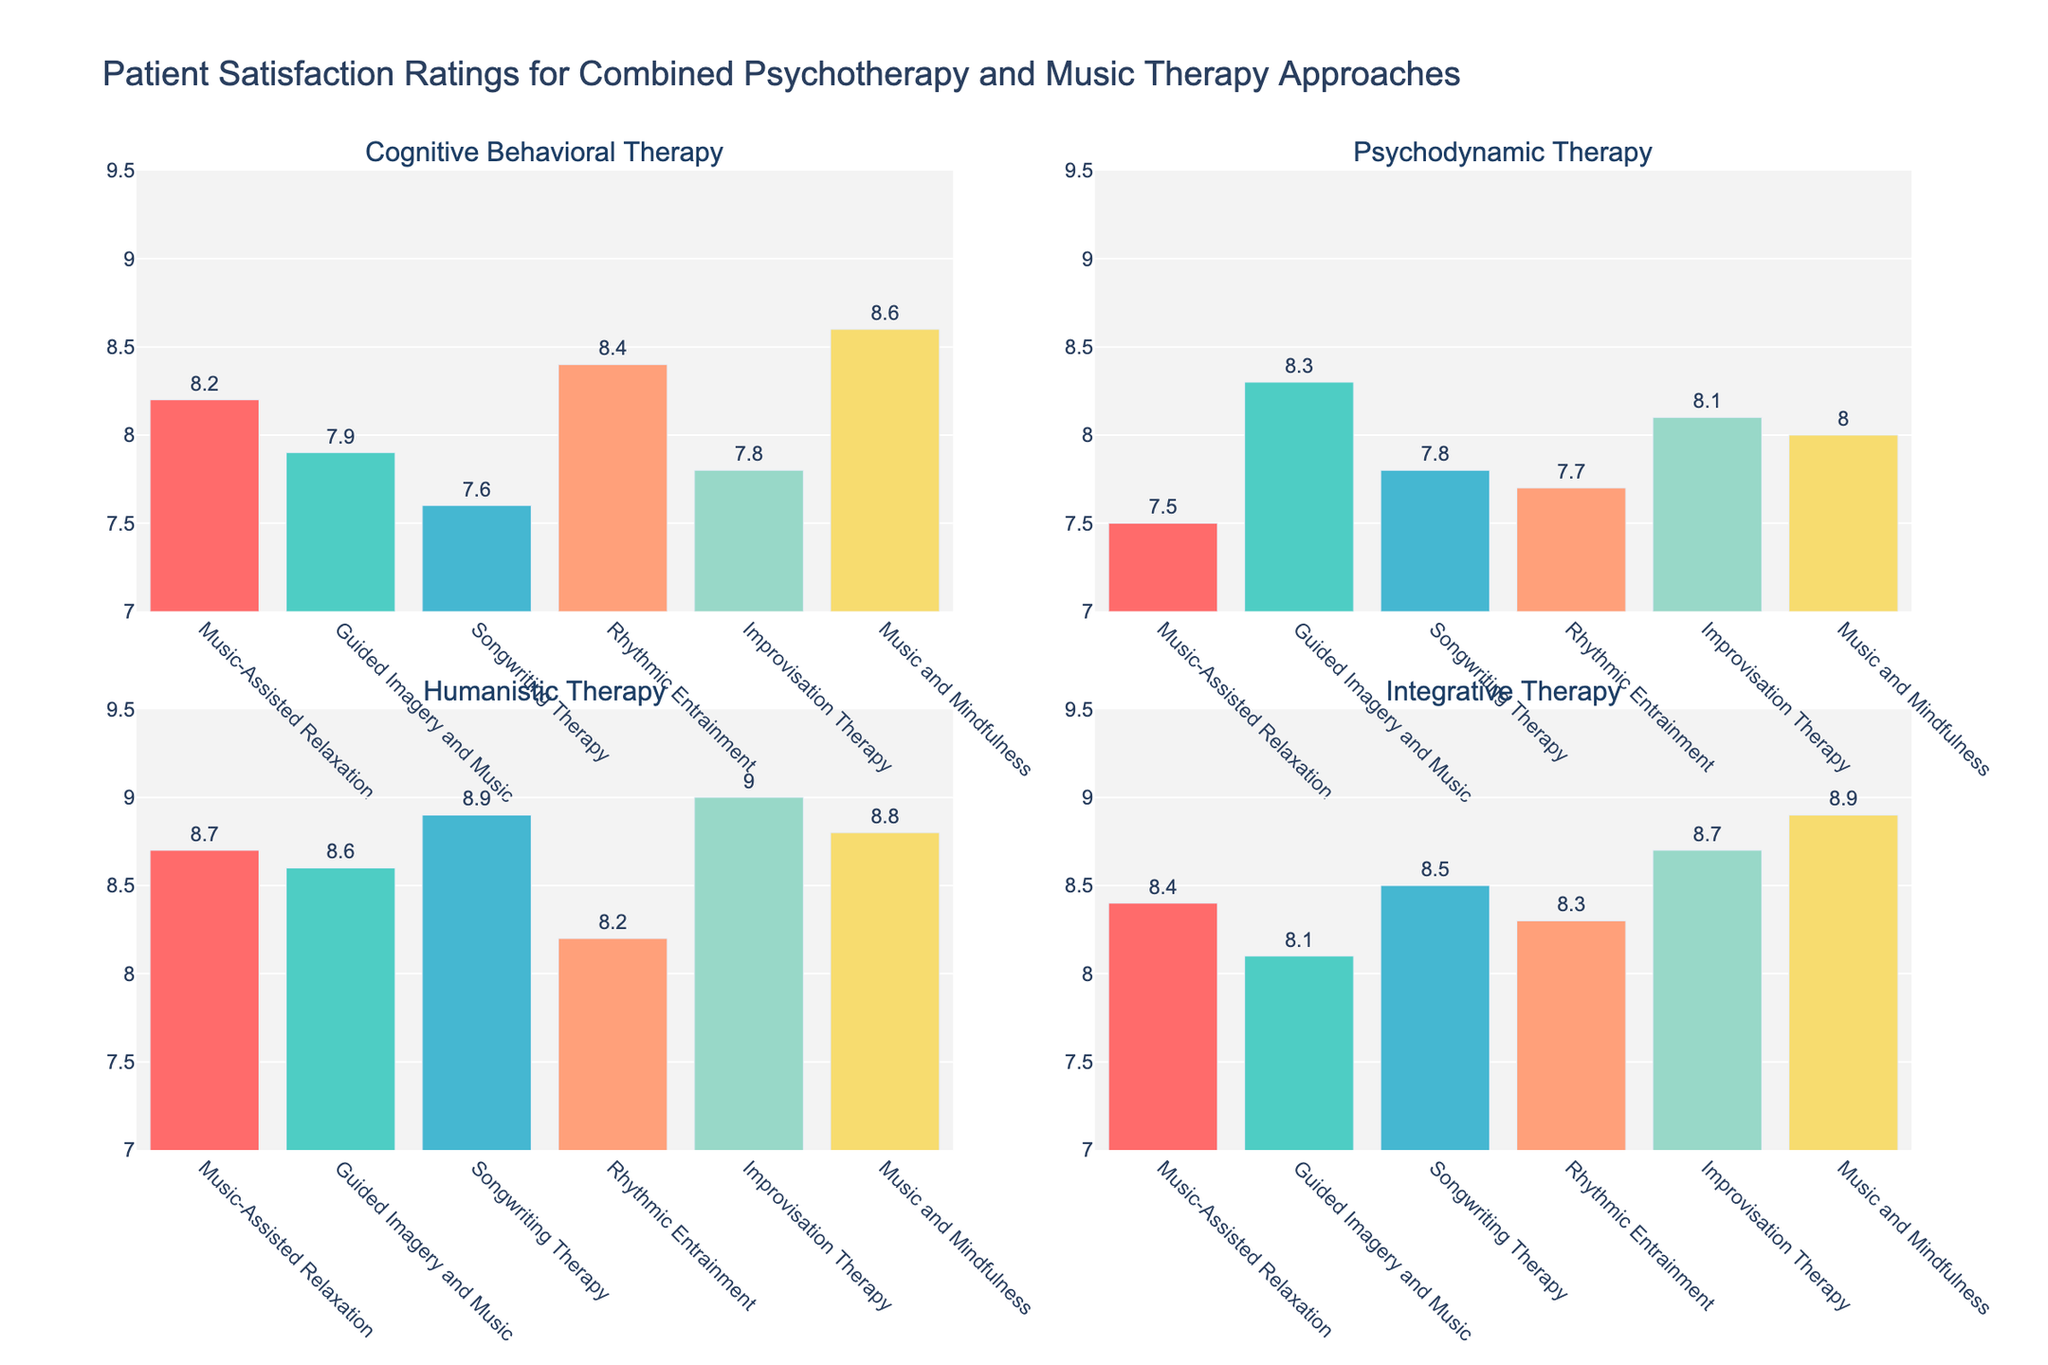What is the title of the figure? The title is typically located at the top of the figure. In this case, it is "Patient Satisfaction Ratings for Combined Psychotherapy and Music Therapy Approaches".
Answer: Patient Satisfaction Ratings for Combined Psychotherapy and Music Therapy Approaches How many combined approaches were evaluated in the figure? Count the number of labels on the x-axis of any subplot. In this figure, there are six approaches evaluated.
Answer: Six Which combined approach received the highest satisfaction rating across all therapies? Find the highest bar across all subplots. The highest value is 9.0 for "Improvisation Therapy" under "Humanistic Therapy".
Answer: Improvisation Therapy Which two combined approaches had the closest patient satisfaction ratings under "Cognitive Behavioral Therapy"? Examine the heights of the bars in the "Cognitive Behavioral Therapy" subplot. The closest ratings are 7.8 for "Improvisation Therapy" and 7.9 for "Guided Imagery and Music".
Answer: Improvisation Therapy and Guided Imagery and Music What is the average patient satisfaction rating for "Music-Assisted Relaxation" across all therapies? Add the scores for "Music-Assisted Relaxation" across all subplots and divide by the number of therapies. (8.2 + 7.5 + 8.7 + 8.4) / 4 = 8.2.
Answer: 8.2 Under "Integrative Therapy," how much higher is the satisfaction rating for "Improvisation Therapy" compared to "Guided Imagery and Music"? Subtract the value of "Guided Imagery and Music" from "Improvisation Therapy" under "Integrative Therapy". 8.7 - 8.1 = 0.6.
Answer: 0.6 Which type of psychotherapy has the most consistent patient satisfaction ratings across all combined music therapy approaches? Find the subplot where the range (difference between the highest and lowest rating) is the smallest. "Cognitive Behavioral Therapy" has ratings from 7.6 to 8.6, a range of 1.0.
Answer: Cognitive Behavioral Therapy Under "Psychodynamic Therapy", which combined approach had the lowest rating? Look at the bars in the "Psychodynamic Therapy" subplot and identify the lowest one. The lowest rating is 7.5 for "Music-Assisted Relaxation".
Answer: Music-Assisted Relaxation What is the total patient satisfaction rating for all combined approaches under "Humanistic Therapy"? Sum the satisfaction ratings for all combined approaches under "Humanistic Therapy". 8.7 + 8.6 + 8.9 + 8.2 + 9.0 + 8.8 = 52.2.
Answer: 52.2 